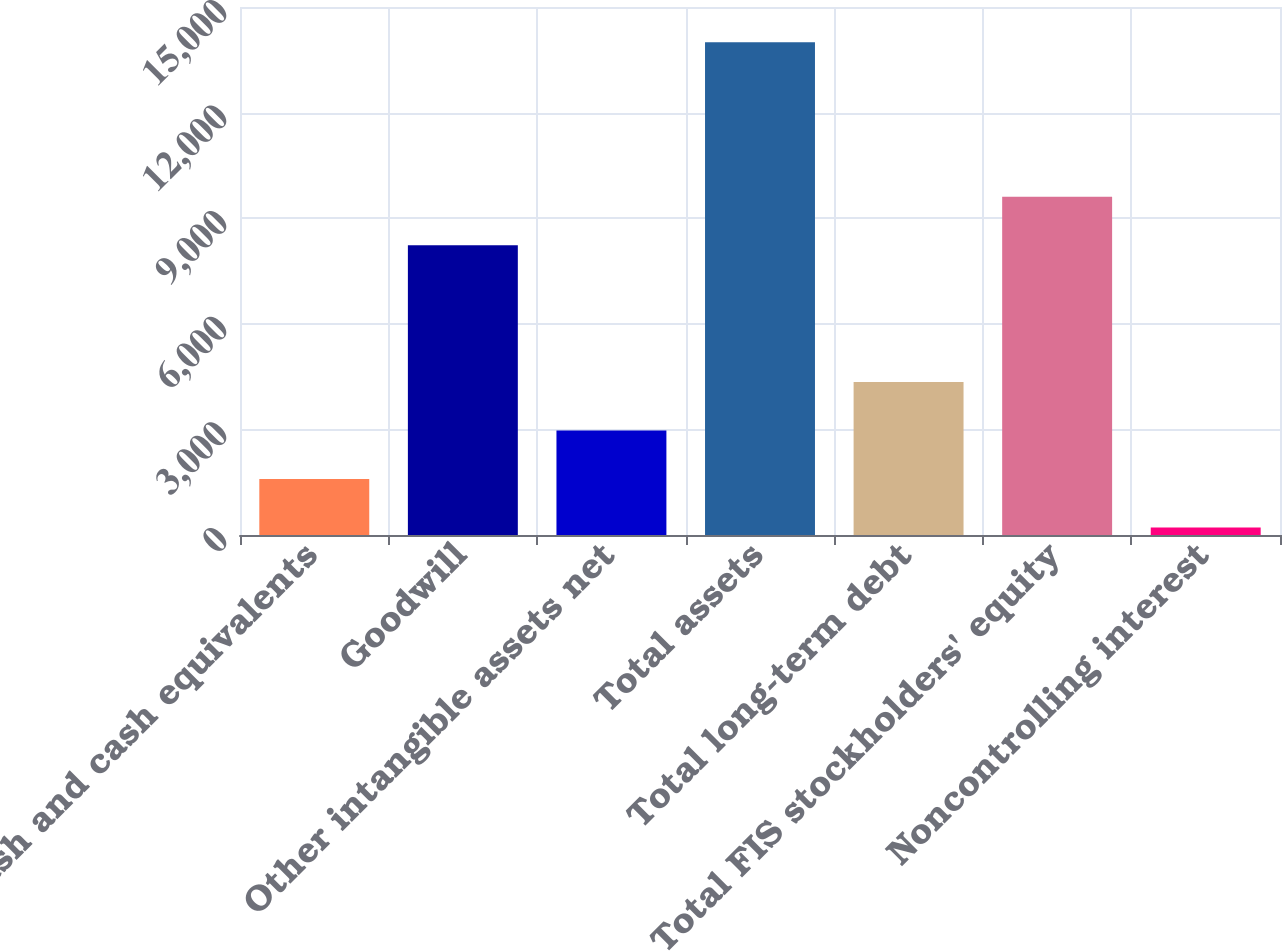Convert chart to OTSL. <chart><loc_0><loc_0><loc_500><loc_500><bar_chart><fcel>Cash and cash equivalents<fcel>Goodwill<fcel>Other intangible assets net<fcel>Total assets<fcel>Total long-term debt<fcel>Total FIS stockholders' equity<fcel>Noncontrolling interest<nl><fcel>1588.49<fcel>8232.9<fcel>2967.28<fcel>13997.6<fcel>4346.07<fcel>9611.69<fcel>209.7<nl></chart> 